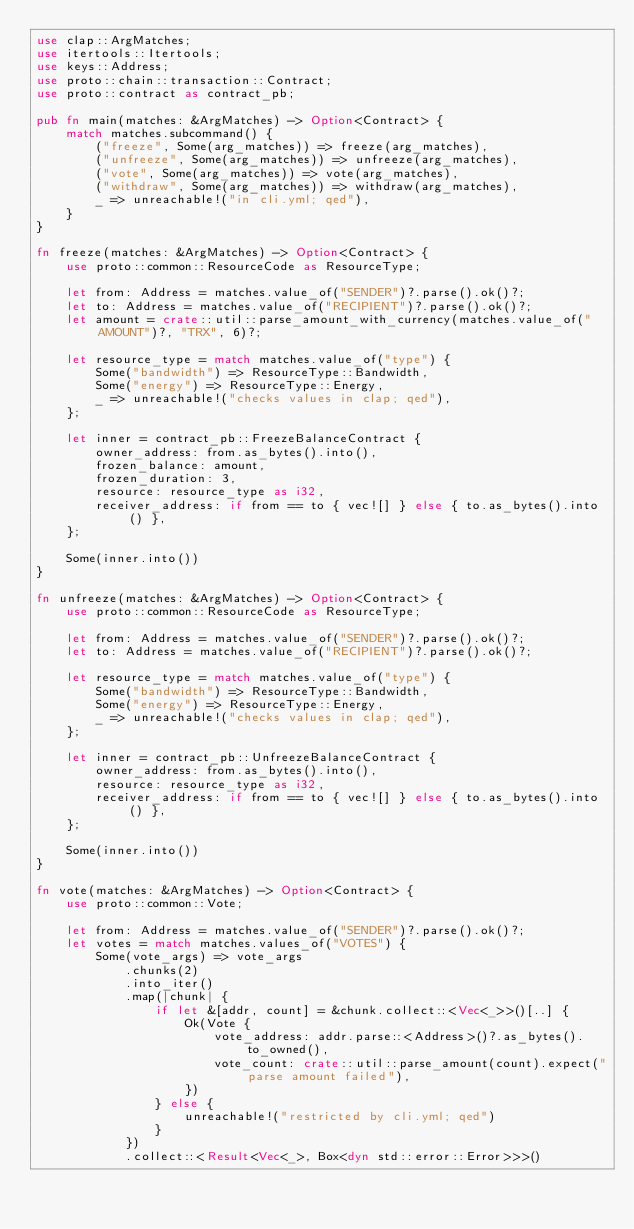<code> <loc_0><loc_0><loc_500><loc_500><_Rust_>use clap::ArgMatches;
use itertools::Itertools;
use keys::Address;
use proto::chain::transaction::Contract;
use proto::contract as contract_pb;

pub fn main(matches: &ArgMatches) -> Option<Contract> {
    match matches.subcommand() {
        ("freeze", Some(arg_matches)) => freeze(arg_matches),
        ("unfreeze", Some(arg_matches)) => unfreeze(arg_matches),
        ("vote", Some(arg_matches)) => vote(arg_matches),
        ("withdraw", Some(arg_matches)) => withdraw(arg_matches),
        _ => unreachable!("in cli.yml; qed"),
    }
}

fn freeze(matches: &ArgMatches) -> Option<Contract> {
    use proto::common::ResourceCode as ResourceType;

    let from: Address = matches.value_of("SENDER")?.parse().ok()?;
    let to: Address = matches.value_of("RECIPIENT")?.parse().ok()?;
    let amount = crate::util::parse_amount_with_currency(matches.value_of("AMOUNT")?, "TRX", 6)?;

    let resource_type = match matches.value_of("type") {
        Some("bandwidth") => ResourceType::Bandwidth,
        Some("energy") => ResourceType::Energy,
        _ => unreachable!("checks values in clap; qed"),
    };

    let inner = contract_pb::FreezeBalanceContract {
        owner_address: from.as_bytes().into(),
        frozen_balance: amount,
        frozen_duration: 3,
        resource: resource_type as i32,
        receiver_address: if from == to { vec![] } else { to.as_bytes().into() },
    };

    Some(inner.into())
}

fn unfreeze(matches: &ArgMatches) -> Option<Contract> {
    use proto::common::ResourceCode as ResourceType;

    let from: Address = matches.value_of("SENDER")?.parse().ok()?;
    let to: Address = matches.value_of("RECIPIENT")?.parse().ok()?;

    let resource_type = match matches.value_of("type") {
        Some("bandwidth") => ResourceType::Bandwidth,
        Some("energy") => ResourceType::Energy,
        _ => unreachable!("checks values in clap; qed"),
    };

    let inner = contract_pb::UnfreezeBalanceContract {
        owner_address: from.as_bytes().into(),
        resource: resource_type as i32,
        receiver_address: if from == to { vec![] } else { to.as_bytes().into() },
    };

    Some(inner.into())
}

fn vote(matches: &ArgMatches) -> Option<Contract> {
    use proto::common::Vote;

    let from: Address = matches.value_of("SENDER")?.parse().ok()?;
    let votes = match matches.values_of("VOTES") {
        Some(vote_args) => vote_args
            .chunks(2)
            .into_iter()
            .map(|chunk| {
                if let &[addr, count] = &chunk.collect::<Vec<_>>()[..] {
                    Ok(Vote {
                        vote_address: addr.parse::<Address>()?.as_bytes().to_owned(),
                        vote_count: crate::util::parse_amount(count).expect("parse amount failed"),
                    })
                } else {
                    unreachable!("restricted by cli.yml; qed")
                }
            })
            .collect::<Result<Vec<_>, Box<dyn std::error::Error>>>()</code> 